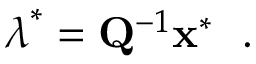<formula> <loc_0><loc_0><loc_500><loc_500>\lambda ^ { * } = Q ^ { - 1 } x ^ { * } \ .</formula> 